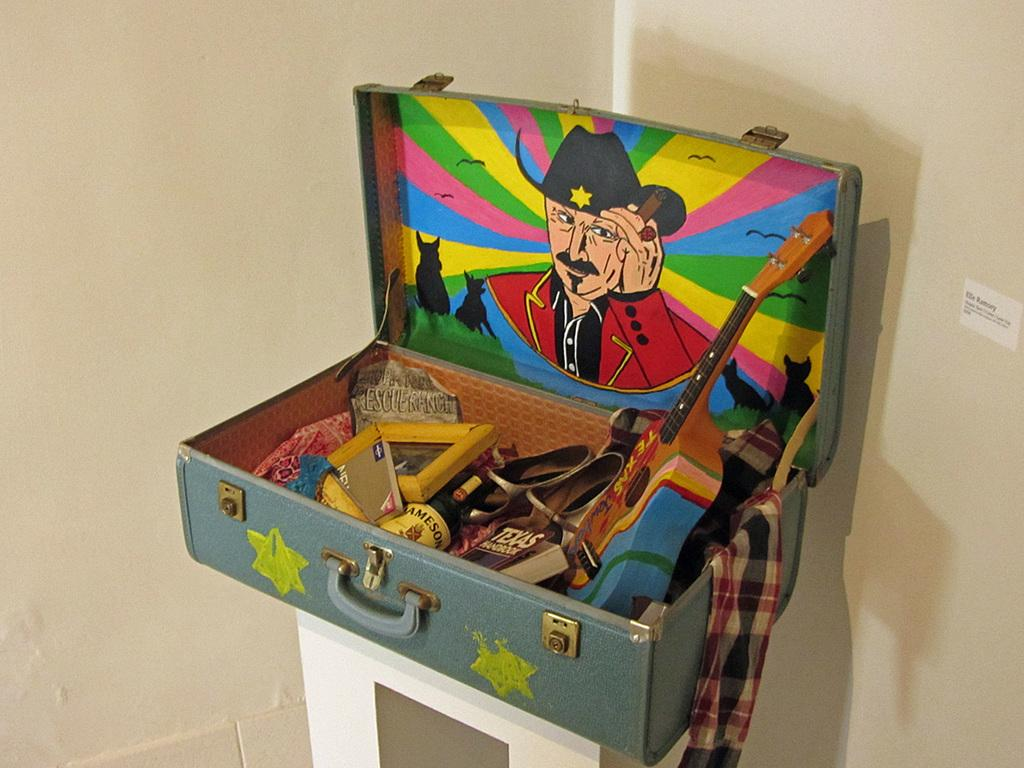What is placed on the table in the image? There is a box placed on a table. What is inside the box? There are objects inside the box. Can you describe one of the objects inside the box? There is a guitar inside the box. What type of gate can be seen in the image? There is no gate present in the image; it features a box with a guitar inside. What role does the hand play in the image? There is no hand present in the image, as it only shows a box with a guitar inside. 